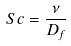<formula> <loc_0><loc_0><loc_500><loc_500>S c = \frac { \nu } { D _ { f } }</formula> 